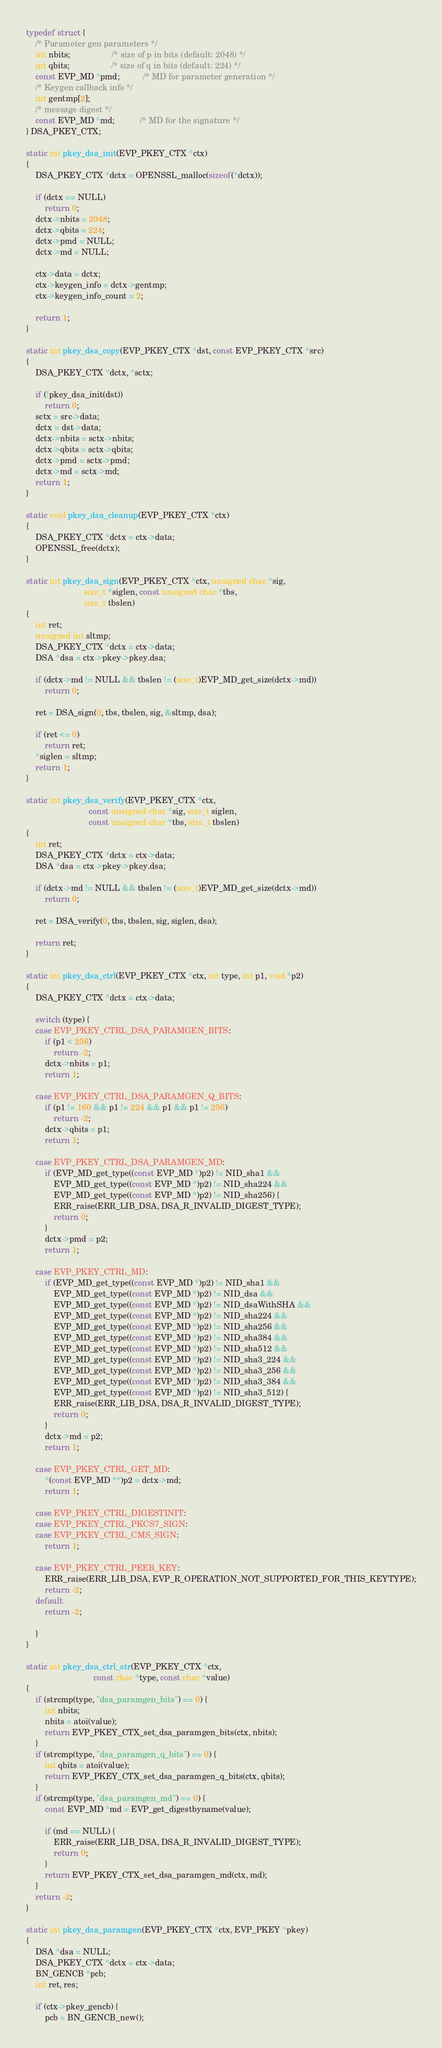Convert code to text. <code><loc_0><loc_0><loc_500><loc_500><_C_>typedef struct {
    /* Parameter gen parameters */
    int nbits;                  /* size of p in bits (default: 2048) */
    int qbits;                  /* size of q in bits (default: 224) */
    const EVP_MD *pmd;          /* MD for parameter generation */
    /* Keygen callback info */
    int gentmp[2];
    /* message digest */
    const EVP_MD *md;           /* MD for the signature */
} DSA_PKEY_CTX;

static int pkey_dsa_init(EVP_PKEY_CTX *ctx)
{
    DSA_PKEY_CTX *dctx = OPENSSL_malloc(sizeof(*dctx));

    if (dctx == NULL)
        return 0;
    dctx->nbits = 2048;
    dctx->qbits = 224;
    dctx->pmd = NULL;
    dctx->md = NULL;

    ctx->data = dctx;
    ctx->keygen_info = dctx->gentmp;
    ctx->keygen_info_count = 2;

    return 1;
}

static int pkey_dsa_copy(EVP_PKEY_CTX *dst, const EVP_PKEY_CTX *src)
{
    DSA_PKEY_CTX *dctx, *sctx;

    if (!pkey_dsa_init(dst))
        return 0;
    sctx = src->data;
    dctx = dst->data;
    dctx->nbits = sctx->nbits;
    dctx->qbits = sctx->qbits;
    dctx->pmd = sctx->pmd;
    dctx->md = sctx->md;
    return 1;
}

static void pkey_dsa_cleanup(EVP_PKEY_CTX *ctx)
{
    DSA_PKEY_CTX *dctx = ctx->data;
    OPENSSL_free(dctx);
}

static int pkey_dsa_sign(EVP_PKEY_CTX *ctx, unsigned char *sig,
                         size_t *siglen, const unsigned char *tbs,
                         size_t tbslen)
{
    int ret;
    unsigned int sltmp;
    DSA_PKEY_CTX *dctx = ctx->data;
    DSA *dsa = ctx->pkey->pkey.dsa;

    if (dctx->md != NULL && tbslen != (size_t)EVP_MD_get_size(dctx->md))
        return 0;

    ret = DSA_sign(0, tbs, tbslen, sig, &sltmp, dsa);

    if (ret <= 0)
        return ret;
    *siglen = sltmp;
    return 1;
}

static int pkey_dsa_verify(EVP_PKEY_CTX *ctx,
                           const unsigned char *sig, size_t siglen,
                           const unsigned char *tbs, size_t tbslen)
{
    int ret;
    DSA_PKEY_CTX *dctx = ctx->data;
    DSA *dsa = ctx->pkey->pkey.dsa;

    if (dctx->md != NULL && tbslen != (size_t)EVP_MD_get_size(dctx->md))
        return 0;

    ret = DSA_verify(0, tbs, tbslen, sig, siglen, dsa);

    return ret;
}

static int pkey_dsa_ctrl(EVP_PKEY_CTX *ctx, int type, int p1, void *p2)
{
    DSA_PKEY_CTX *dctx = ctx->data;

    switch (type) {
    case EVP_PKEY_CTRL_DSA_PARAMGEN_BITS:
        if (p1 < 256)
            return -2;
        dctx->nbits = p1;
        return 1;

    case EVP_PKEY_CTRL_DSA_PARAMGEN_Q_BITS:
        if (p1 != 160 && p1 != 224 && p1 && p1 != 256)
            return -2;
        dctx->qbits = p1;
        return 1;

    case EVP_PKEY_CTRL_DSA_PARAMGEN_MD:
        if (EVP_MD_get_type((const EVP_MD *)p2) != NID_sha1 &&
            EVP_MD_get_type((const EVP_MD *)p2) != NID_sha224 &&
            EVP_MD_get_type((const EVP_MD *)p2) != NID_sha256) {
            ERR_raise(ERR_LIB_DSA, DSA_R_INVALID_DIGEST_TYPE);
            return 0;
        }
        dctx->pmd = p2;
        return 1;

    case EVP_PKEY_CTRL_MD:
        if (EVP_MD_get_type((const EVP_MD *)p2) != NID_sha1 &&
            EVP_MD_get_type((const EVP_MD *)p2) != NID_dsa &&
            EVP_MD_get_type((const EVP_MD *)p2) != NID_dsaWithSHA &&
            EVP_MD_get_type((const EVP_MD *)p2) != NID_sha224 &&
            EVP_MD_get_type((const EVP_MD *)p2) != NID_sha256 &&
            EVP_MD_get_type((const EVP_MD *)p2) != NID_sha384 &&
            EVP_MD_get_type((const EVP_MD *)p2) != NID_sha512 &&
            EVP_MD_get_type((const EVP_MD *)p2) != NID_sha3_224 &&
            EVP_MD_get_type((const EVP_MD *)p2) != NID_sha3_256 &&
            EVP_MD_get_type((const EVP_MD *)p2) != NID_sha3_384 &&
            EVP_MD_get_type((const EVP_MD *)p2) != NID_sha3_512) {
            ERR_raise(ERR_LIB_DSA, DSA_R_INVALID_DIGEST_TYPE);
            return 0;
        }
        dctx->md = p2;
        return 1;

    case EVP_PKEY_CTRL_GET_MD:
        *(const EVP_MD **)p2 = dctx->md;
        return 1;

    case EVP_PKEY_CTRL_DIGESTINIT:
    case EVP_PKEY_CTRL_PKCS7_SIGN:
    case EVP_PKEY_CTRL_CMS_SIGN:
        return 1;

    case EVP_PKEY_CTRL_PEER_KEY:
        ERR_raise(ERR_LIB_DSA, EVP_R_OPERATION_NOT_SUPPORTED_FOR_THIS_KEYTYPE);
        return -2;
    default:
        return -2;

    }
}

static int pkey_dsa_ctrl_str(EVP_PKEY_CTX *ctx,
                             const char *type, const char *value)
{
    if (strcmp(type, "dsa_paramgen_bits") == 0) {
        int nbits;
        nbits = atoi(value);
        return EVP_PKEY_CTX_set_dsa_paramgen_bits(ctx, nbits);
    }
    if (strcmp(type, "dsa_paramgen_q_bits") == 0) {
        int qbits = atoi(value);
        return EVP_PKEY_CTX_set_dsa_paramgen_q_bits(ctx, qbits);
    }
    if (strcmp(type, "dsa_paramgen_md") == 0) {
        const EVP_MD *md = EVP_get_digestbyname(value);

        if (md == NULL) {
            ERR_raise(ERR_LIB_DSA, DSA_R_INVALID_DIGEST_TYPE);
            return 0;
        }
        return EVP_PKEY_CTX_set_dsa_paramgen_md(ctx, md);
    }
    return -2;
}

static int pkey_dsa_paramgen(EVP_PKEY_CTX *ctx, EVP_PKEY *pkey)
{
    DSA *dsa = NULL;
    DSA_PKEY_CTX *dctx = ctx->data;
    BN_GENCB *pcb;
    int ret, res;

    if (ctx->pkey_gencb) {
        pcb = BN_GENCB_new();</code> 